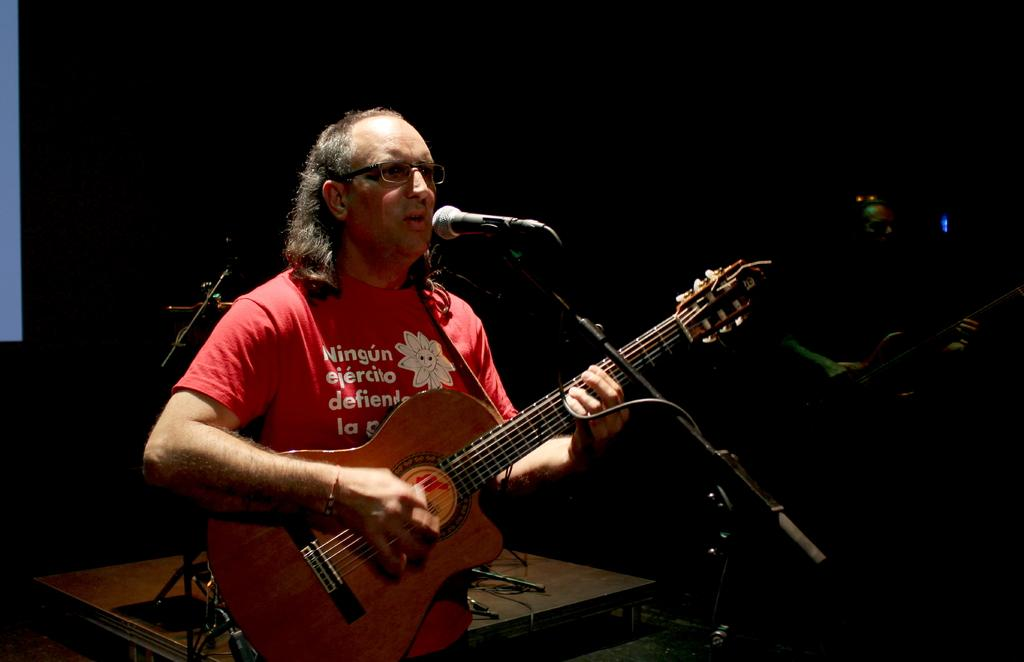What is the man in the image holding? The man is holding a guitar. What is in front of the man? There is a microphone in front of the man. What can be seen on the man's face? The man is wearing glasses (specs). What color is the man's t-shirt? The man is wearing a red t-shirt. What type of secretary can be seen assisting the man in the image? There is no secretary present in the image. Is the man using a pail to play the guitar in the image? There is no pail present in the image, and the man is not using any object to play the guitar. 